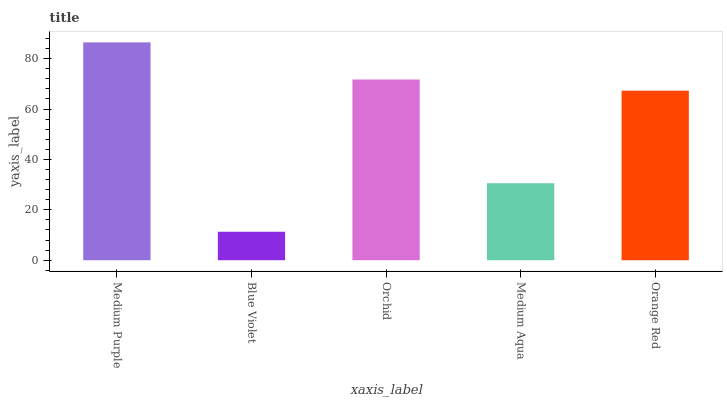Is Blue Violet the minimum?
Answer yes or no. Yes. Is Medium Purple the maximum?
Answer yes or no. Yes. Is Orchid the minimum?
Answer yes or no. No. Is Orchid the maximum?
Answer yes or no. No. Is Orchid greater than Blue Violet?
Answer yes or no. Yes. Is Blue Violet less than Orchid?
Answer yes or no. Yes. Is Blue Violet greater than Orchid?
Answer yes or no. No. Is Orchid less than Blue Violet?
Answer yes or no. No. Is Orange Red the high median?
Answer yes or no. Yes. Is Orange Red the low median?
Answer yes or no. Yes. Is Medium Purple the high median?
Answer yes or no. No. Is Medium Purple the low median?
Answer yes or no. No. 